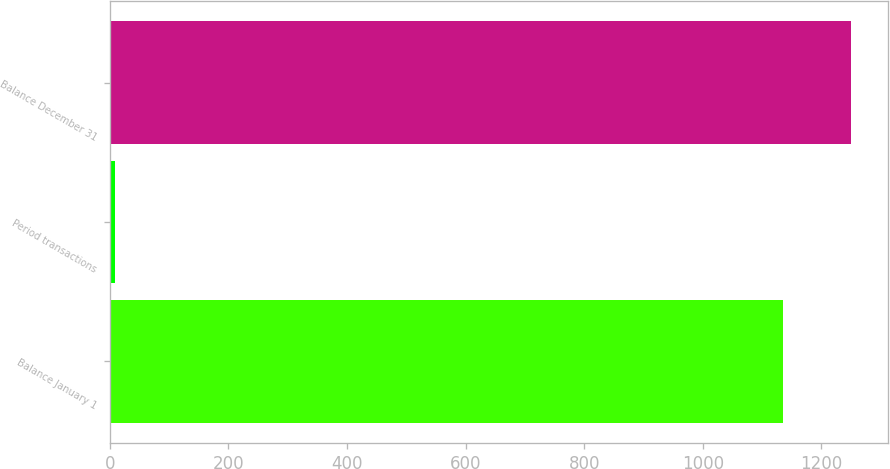<chart> <loc_0><loc_0><loc_500><loc_500><bar_chart><fcel>Balance January 1<fcel>Period transactions<fcel>Balance December 31<nl><fcel>1136<fcel>8<fcel>1249.6<nl></chart> 